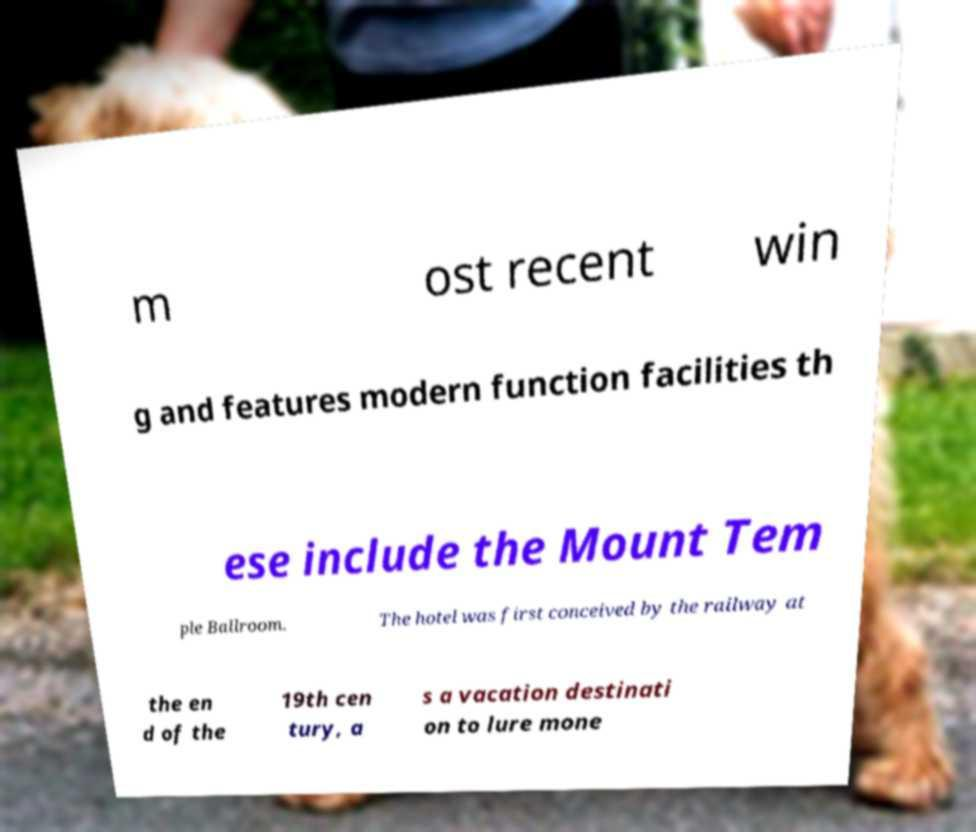For documentation purposes, I need the text within this image transcribed. Could you provide that? m ost recent win g and features modern function facilities th ese include the Mount Tem ple Ballroom. The hotel was first conceived by the railway at the en d of the 19th cen tury, a s a vacation destinati on to lure mone 